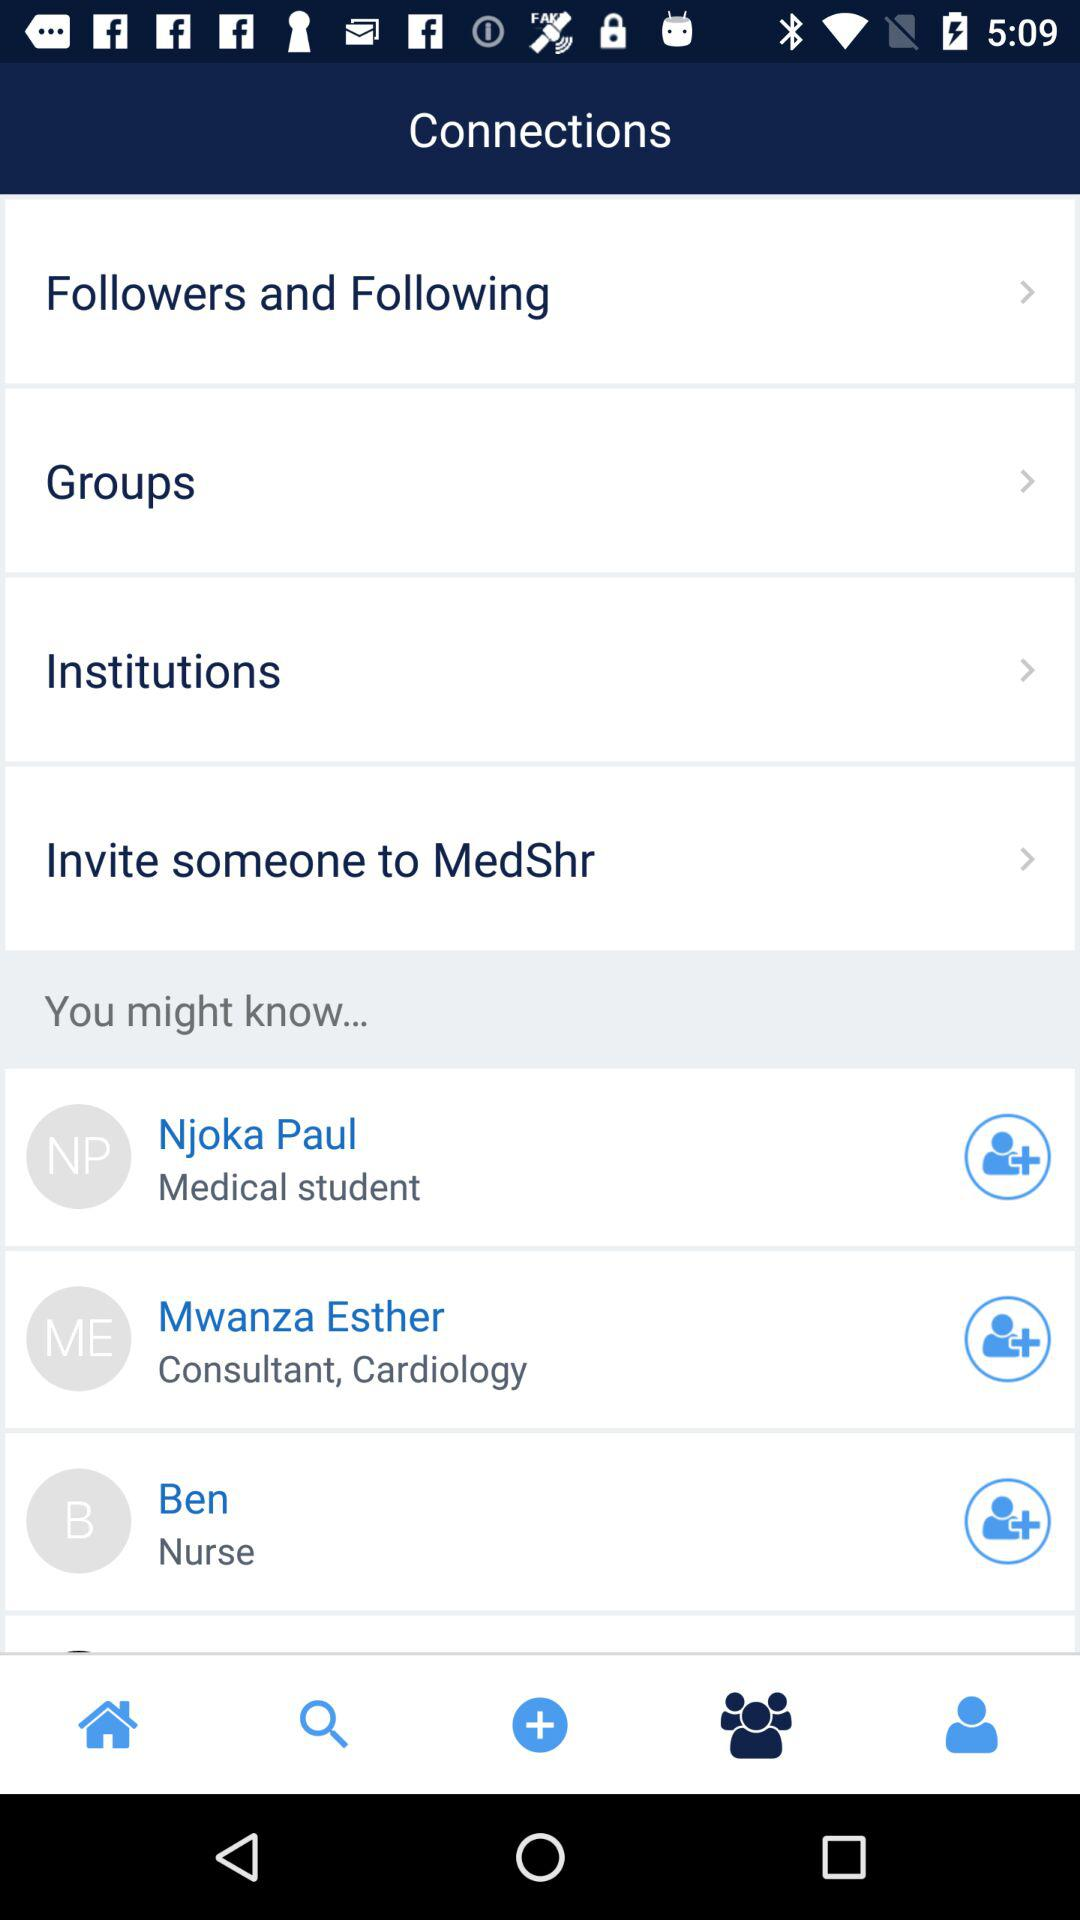How many items are in the 'You might know' section?
Answer the question using a single word or phrase. 3 